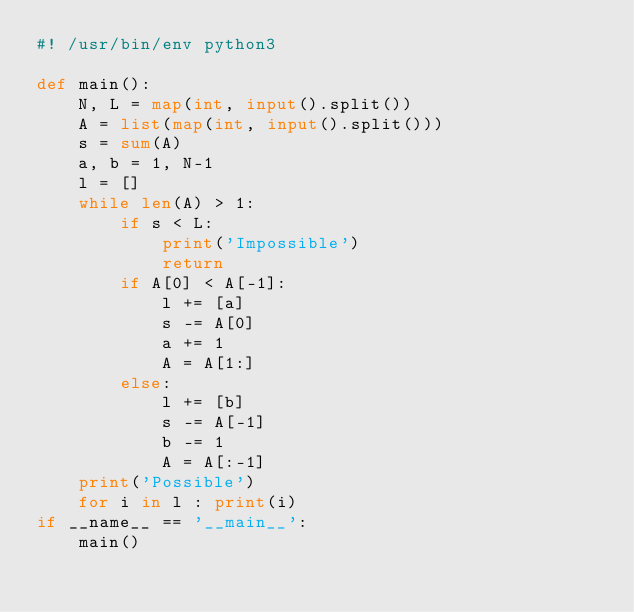<code> <loc_0><loc_0><loc_500><loc_500><_Python_>#! /usr/bin/env python3

def main():
    N, L = map(int, input().split())
    A = list(map(int, input().split()))
    s = sum(A)
    a, b = 1, N-1
    l = []
    while len(A) > 1:
        if s < L:
            print('Impossible')
            return
        if A[0] < A[-1]:
            l += [a]
            s -= A[0]
            a += 1
            A = A[1:]
        else:
            l += [b]
            s -= A[-1]
            b -= 1
            A = A[:-1]
    print('Possible')
    for i in l : print(i)
if __name__ == '__main__':
    main()</code> 